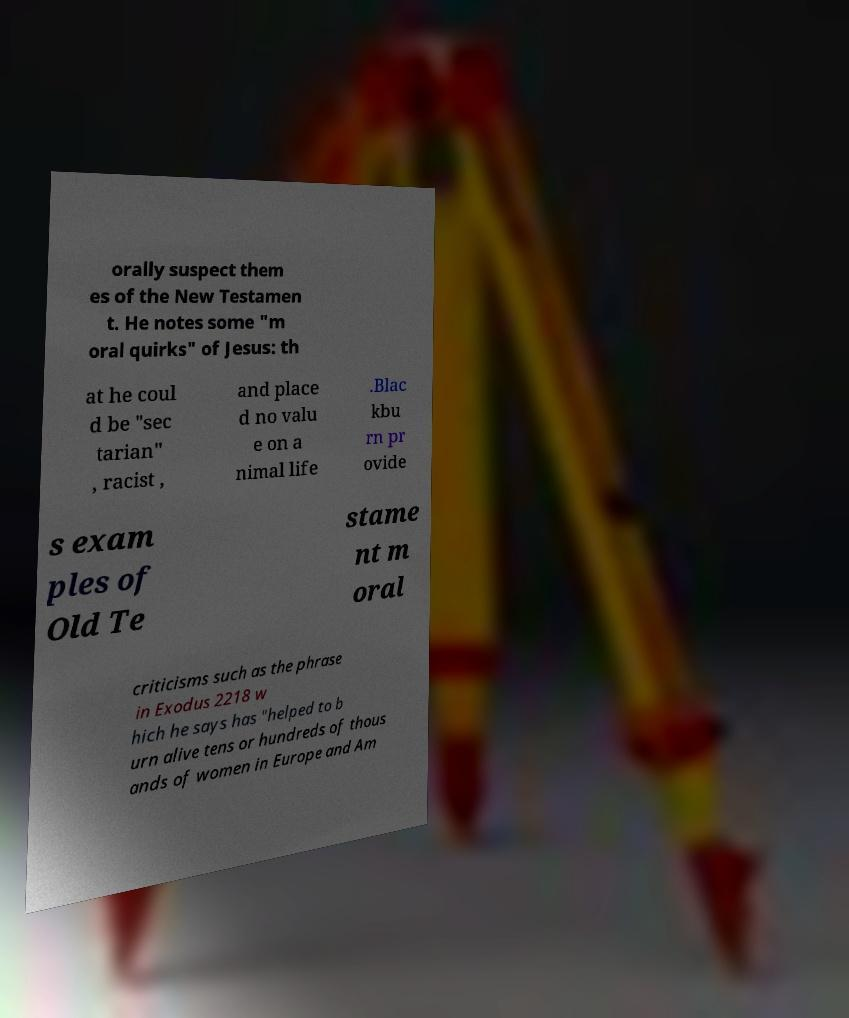I need the written content from this picture converted into text. Can you do that? orally suspect them es of the New Testamen t. He notes some "m oral quirks" of Jesus: th at he coul d be "sec tarian" , racist , and place d no valu e on a nimal life .Blac kbu rn pr ovide s exam ples of Old Te stame nt m oral criticisms such as the phrase in Exodus 2218 w hich he says has "helped to b urn alive tens or hundreds of thous ands of women in Europe and Am 